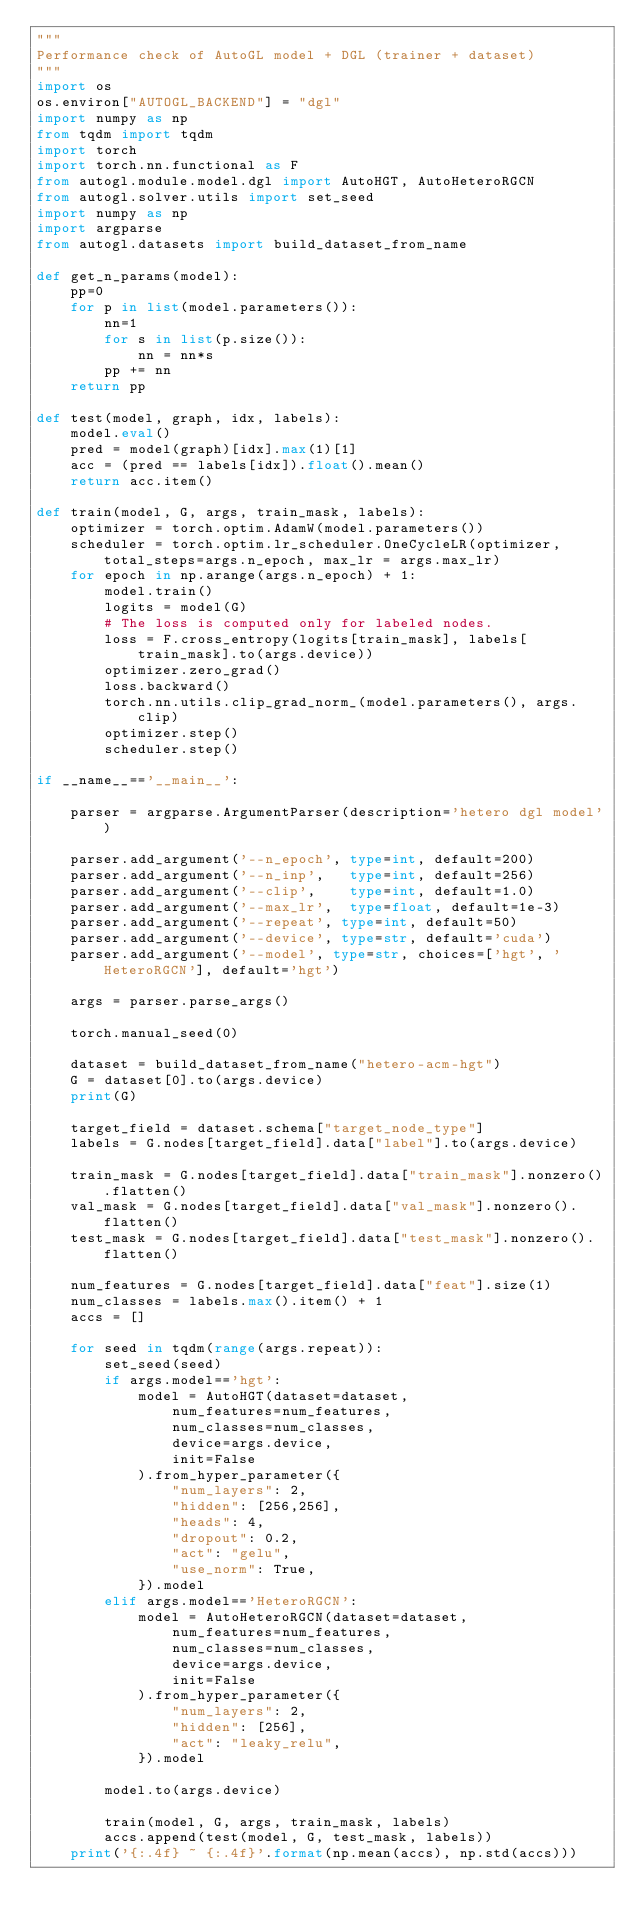Convert code to text. <code><loc_0><loc_0><loc_500><loc_500><_Python_>"""
Performance check of AutoGL model + DGL (trainer + dataset)
"""
import os
os.environ["AUTOGL_BACKEND"] = "dgl"
import numpy as np
from tqdm import tqdm
import torch
import torch.nn.functional as F
from autogl.module.model.dgl import AutoHGT, AutoHeteroRGCN
from autogl.solver.utils import set_seed
import numpy as np
import argparse
from autogl.datasets import build_dataset_from_name

def get_n_params(model):
    pp=0
    for p in list(model.parameters()):
        nn=1
        for s in list(p.size()):
            nn = nn*s
        pp += nn
    return pp

def test(model, graph, idx, labels):
    model.eval()
    pred = model(graph)[idx].max(1)[1]
    acc = (pred == labels[idx]).float().mean()
    return acc.item()

def train(model, G, args, train_mask, labels):
    optimizer = torch.optim.AdamW(model.parameters())
    scheduler = torch.optim.lr_scheduler.OneCycleLR(optimizer, total_steps=args.n_epoch, max_lr = args.max_lr)
    for epoch in np.arange(args.n_epoch) + 1:
        model.train()
        logits = model(G)
        # The loss is computed only for labeled nodes.
        loss = F.cross_entropy(logits[train_mask], labels[train_mask].to(args.device))
        optimizer.zero_grad()
        loss.backward()
        torch.nn.utils.clip_grad_norm_(model.parameters(), args.clip)
        optimizer.step()
        scheduler.step()

if __name__=='__main__':

    parser = argparse.ArgumentParser(description='hetero dgl model')

    parser.add_argument('--n_epoch', type=int, default=200)
    parser.add_argument('--n_inp',   type=int, default=256)
    parser.add_argument('--clip',    type=int, default=1.0) 
    parser.add_argument('--max_lr',  type=float, default=1e-3) 
    parser.add_argument('--repeat', type=int, default=50)
    parser.add_argument('--device', type=str, default='cuda')
    parser.add_argument('--model', type=str, choices=['hgt', 'HeteroRGCN'], default='hgt')

    args = parser.parse_args()

    torch.manual_seed(0)

    dataset = build_dataset_from_name("hetero-acm-hgt")
    G = dataset[0].to(args.device)
    print(G)

    target_field = dataset.schema["target_node_type"]
    labels = G.nodes[target_field].data["label"].to(args.device)

    train_mask = G.nodes[target_field].data["train_mask"].nonzero().flatten()
    val_mask = G.nodes[target_field].data["val_mask"].nonzero().flatten()
    test_mask = G.nodes[target_field].data["test_mask"].nonzero().flatten()

    num_features = G.nodes[target_field].data["feat"].size(1)
    num_classes = labels.max().item() + 1
    accs = []

    for seed in tqdm(range(args.repeat)):
        set_seed(seed)
        if args.model=='hgt':
            model = AutoHGT(dataset=dataset,
                num_features=num_features,
                num_classes=num_classes,
                device=args.device,
                init=False
            ).from_hyper_parameter({
                "num_layers": 2,
                "hidden": [256,256],
                "heads": 4,
                "dropout": 0.2,
                "act": "gelu",
                "use_norm": True,
            }).model
        elif args.model=='HeteroRGCN':
            model = AutoHeteroRGCN(dataset=dataset,
                num_features=num_features,
                num_classes=num_classes,
                device=args.device,
                init=False
            ).from_hyper_parameter({
                "num_layers": 2,
                "hidden": [256],
                "act": "leaky_relu",
            }).model

        model.to(args.device)

        train(model, G, args, train_mask, labels)
        accs.append(test(model, G, test_mask, labels))
    print('{:.4f} ~ {:.4f}'.format(np.mean(accs), np.std(accs)))
</code> 